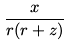Convert formula to latex. <formula><loc_0><loc_0><loc_500><loc_500>\frac { x } { r ( r + z ) }</formula> 